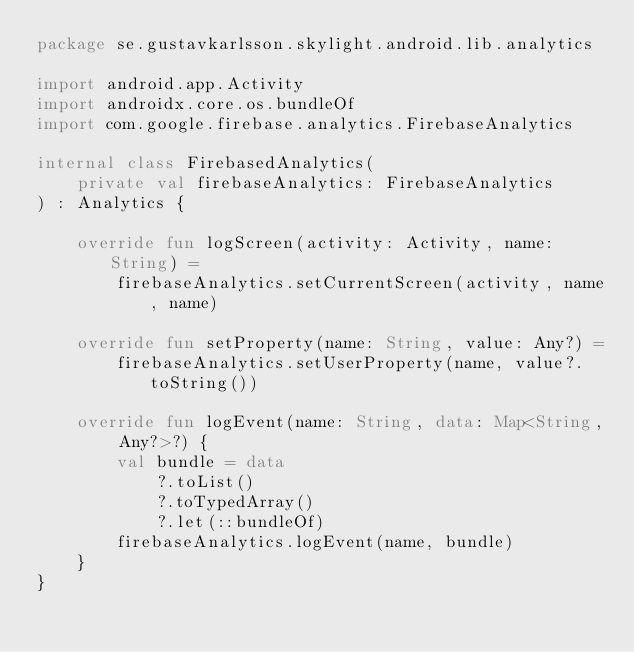<code> <loc_0><loc_0><loc_500><loc_500><_Kotlin_>package se.gustavkarlsson.skylight.android.lib.analytics

import android.app.Activity
import androidx.core.os.bundleOf
import com.google.firebase.analytics.FirebaseAnalytics

internal class FirebasedAnalytics(
    private val firebaseAnalytics: FirebaseAnalytics
) : Analytics {

    override fun logScreen(activity: Activity, name: String) =
        firebaseAnalytics.setCurrentScreen(activity, name, name)

    override fun setProperty(name: String, value: Any?) =
        firebaseAnalytics.setUserProperty(name, value?.toString())

    override fun logEvent(name: String, data: Map<String, Any?>?) {
        val bundle = data
            ?.toList()
            ?.toTypedArray()
            ?.let(::bundleOf)
        firebaseAnalytics.logEvent(name, bundle)
    }
}
</code> 